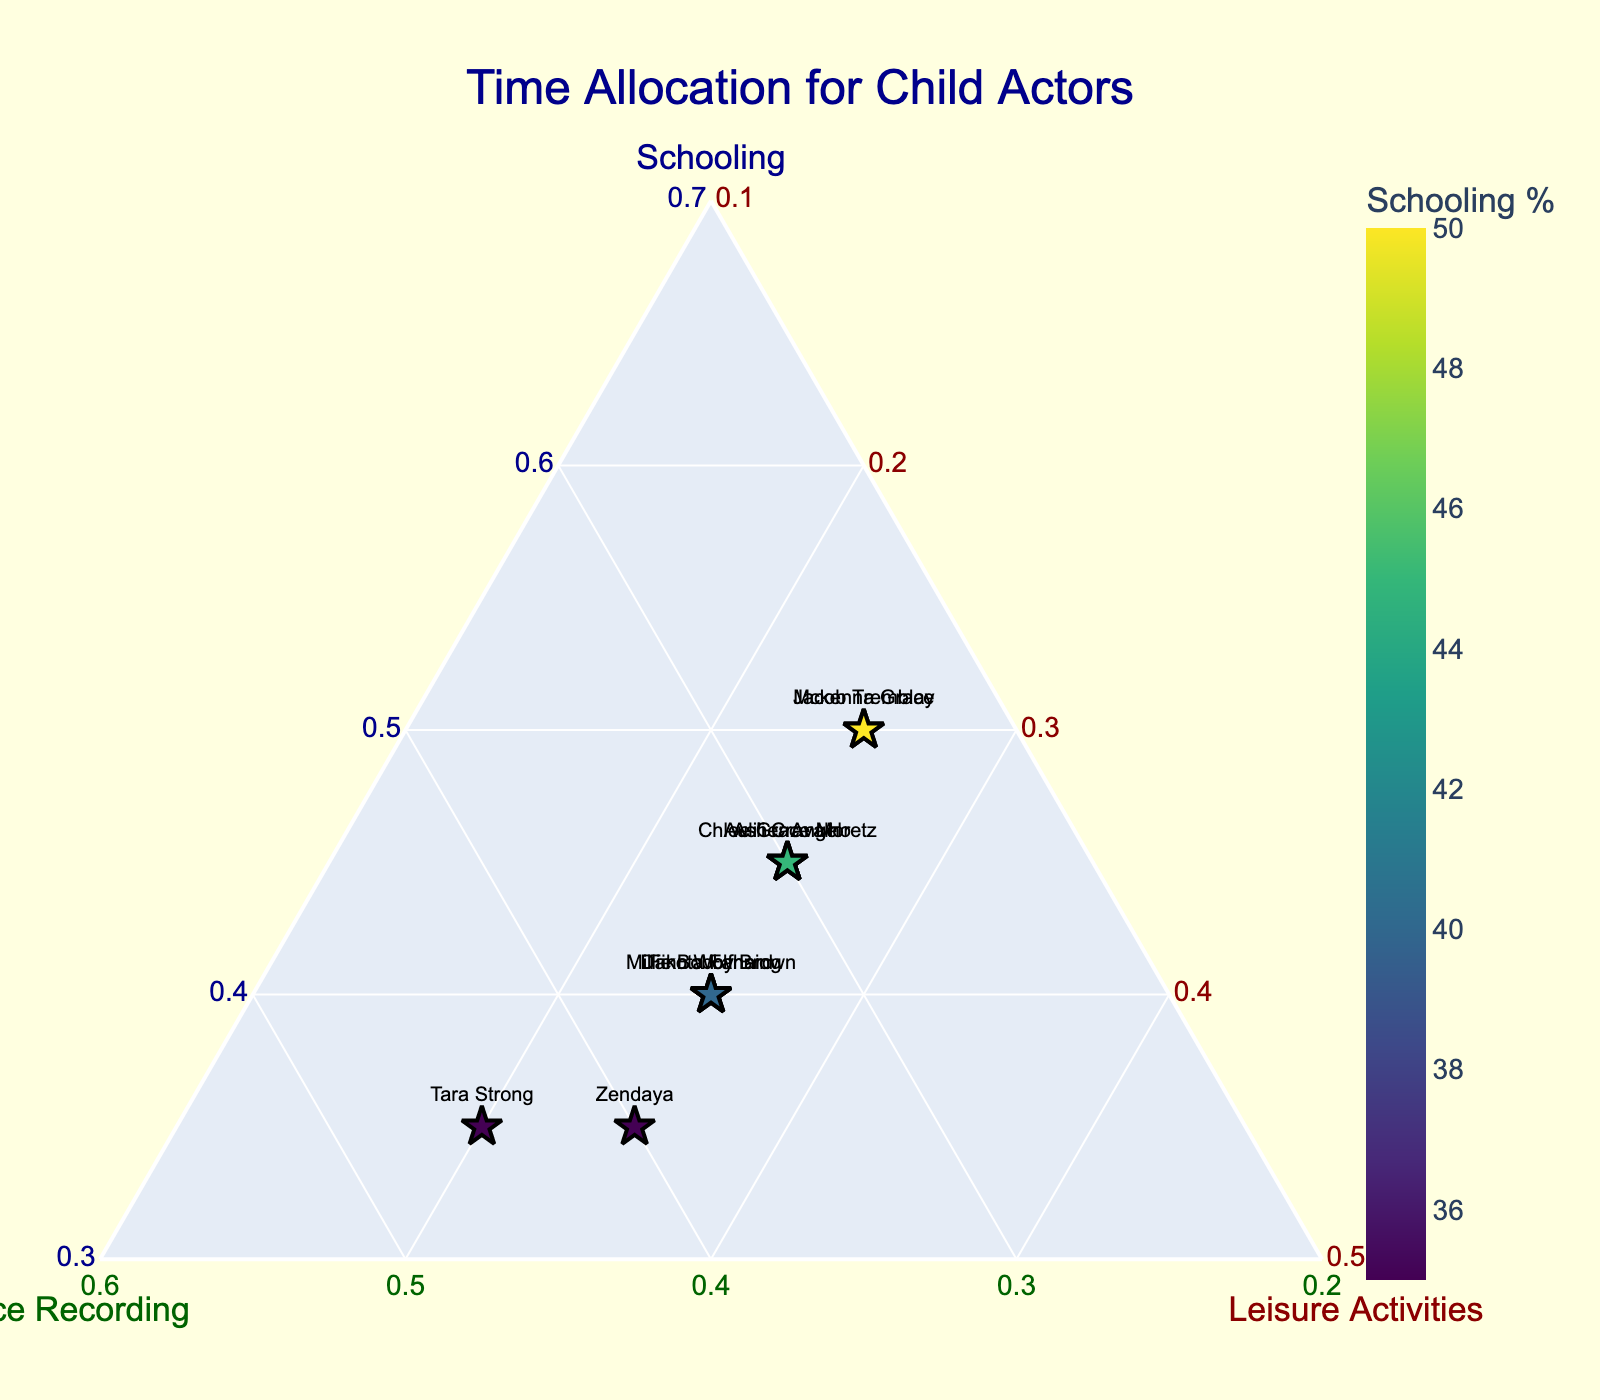Which actor allocates the most time to voice recording? To determine the actor who allocates the most time to voice recording, look for the highest value along the Voice Recording axis. Tara Strong has the highest percentage in voice recording at 45%.
Answer: Tara Strong How many actors allocate 40% of their time to schooling? Check the Schooling axis for points where the percentage is 40%. Dakota Fanning, Finn Wolfhard, and Millie Bobby Brown all allocate 40% of their time to schooling.
Answer: 3 Which actor has the smallest percentage allocated to leisure activities? Look at the lowest value along the Leisure Activities axis. Both Tara Strong and Zendaya have the smallest allocation for leisure activities at 20%.
Answer: Tara Strong and Zendaya What is the title of the plot? The title is located at the top of the plot. It reads "Time Allocation for Child Actors".
Answer: Time Allocation for Child Actors Is the minimum time allocation for schooling more or less than the minimum time allocation for voice recording? The minimum time allocation on the Schooling axis is 35%, while on the Voice Recording axis, it is 25%. Therefore, the minimum allocation for schooling is higher.
Answer: More Which actor's school time allocation equals their leisure activities time allocation? Look for points where the values for Schooling and Leisure Activities are equal. Jacob Tremblay and Mckenna Grace both allocate 50% to schooling and 25% to leisure activities.
Answer: Jacob Tremblay and Mckenna Grace Which actor has the same time allocation for schooling and voice recording? Find the point where the Schooling and Voice Recording allocations are equal. There are no actors who have identical allocations for both schooling and voice recording.
Answer: None What's the average time allocation for leisure activities among all actors? Sum the percentages of leisure activities for all actors and divide by the number of actors. The percentages are 25, 25, 25, 20, 25, 25, 25, 25, 25, and 25. The sum is 240 and the average is 240/10 = 24%.
Answer: 24% Who has a more balanced schedule between the three activities, Dakota Fanning or Zendaya? Compare the percentage allocations for the three activities for each actor. Dakota Fanning allocates 40% to schooling, 35% to voice recording, and 25% to leisure, with the difference between the highest and lowest being 15%. Zendaya allocates 35%, 40%, and 25%, which also has a difference of 15%. Hence, neither has a more balanced schedule over the other.
Answer: Neither Between actors with 45% in schooling, who spends more time in voice recording? Check actors with 45% in schooling and compare their voice recording times. Auli'i Cravalho, Chloe Grace Moretz, and Asher Angel each allocate 45% to schooling. Among them, Auli'i Cravalho and Chloe Grace Moretz both spend 30% and Asher Angel spends 30%. There is no difference.
Answer: None 